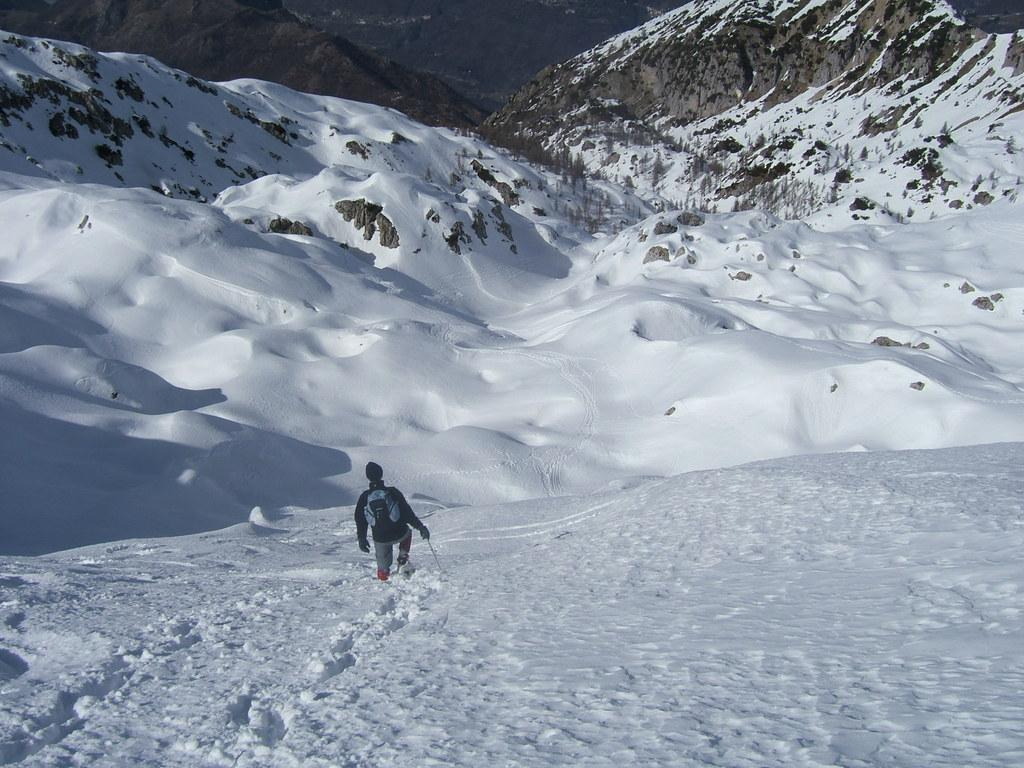What is the person in the image doing? The person is walking in the image. What is the environment like in the image? The person is walking in snow, and there are mountains, trees, and snow in the background of the image. What is the person wearing? The person is wearing a jacket. What is the person carrying? The person is carrying a backpack. What language is the person speaking in the image? There is no indication of the person speaking in the image, so we cannot determine the language they might be using. 